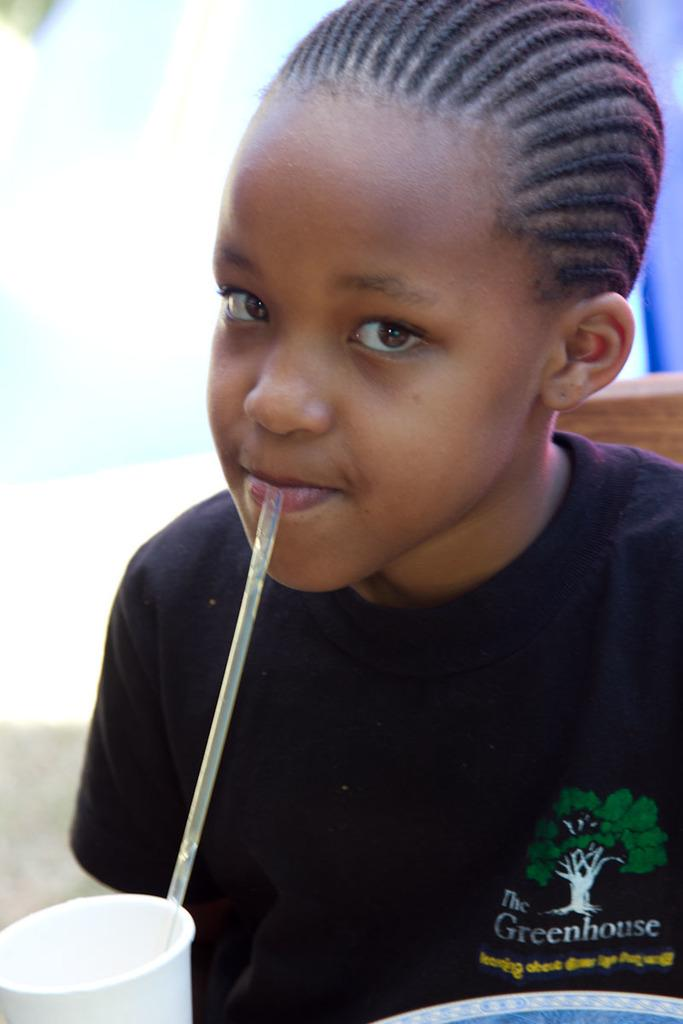What is the main subject of the image? The main subject of the image is a kid. What is the kid wearing in the image? The kid is wearing a black t-shirt. What is the kid doing in the image? The kid is drinking something. How is the kid drinking the liquid in the image? The kid is using a straw. What is the straw placed in? The straw is in a glass. What color is the cap on the kid's head in the image? There is no cap visible on the kid's head in the image. How many cents are shown in the image? There are no cents present in the image. 